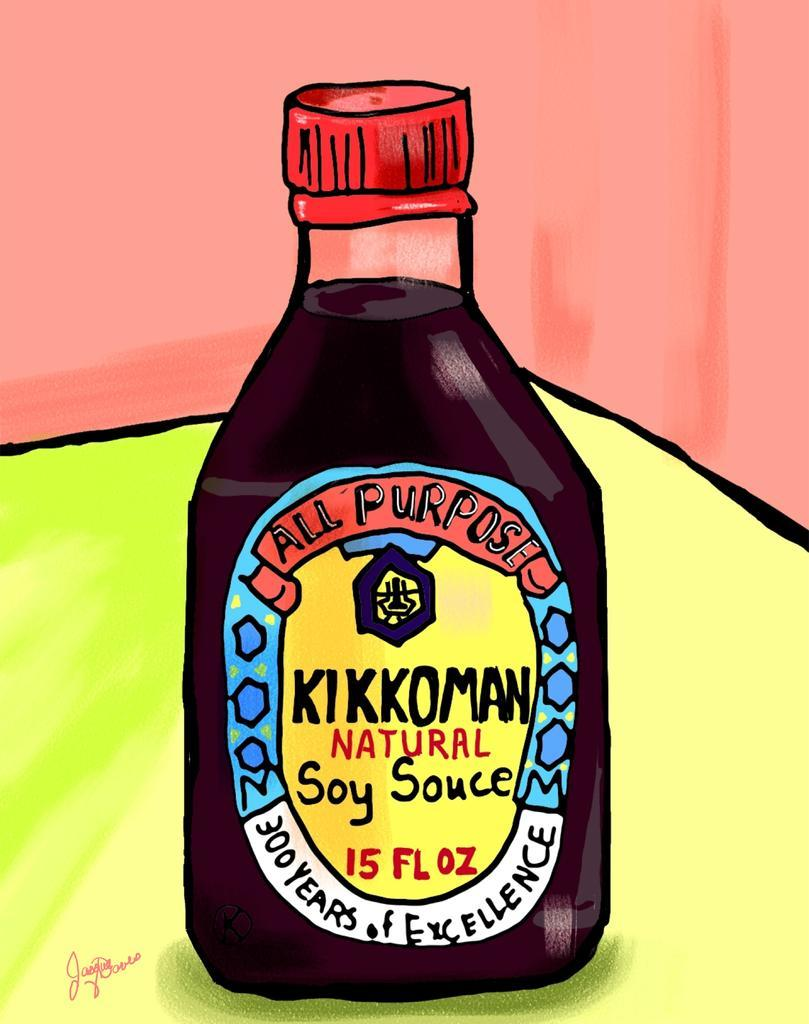<image>
Create a compact narrative representing the image presented. A drawing of a bottle of Kikkoman Soy Sauce. 